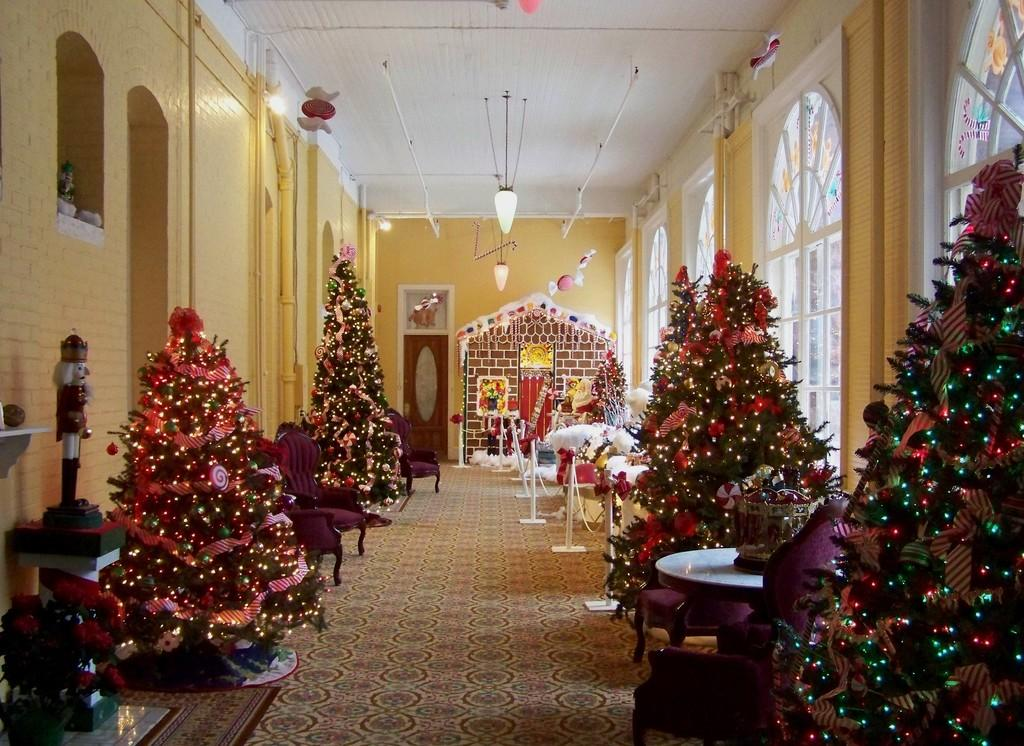What is decorated with lights in the image? There are trees decorated with lights in the image. What type of furniture can be seen in the image? There are tables in the image. What architectural feature is present in the image? There is a railing in the image. What can be seen in the background of the image? There is a wall and ceiling lights in the background of the image. How many cakes are being served on the tables in the image? There is no information about cakes being served on the tables in the image. What type of pie is being cut by someone in the image? There is no pie present in the image. 